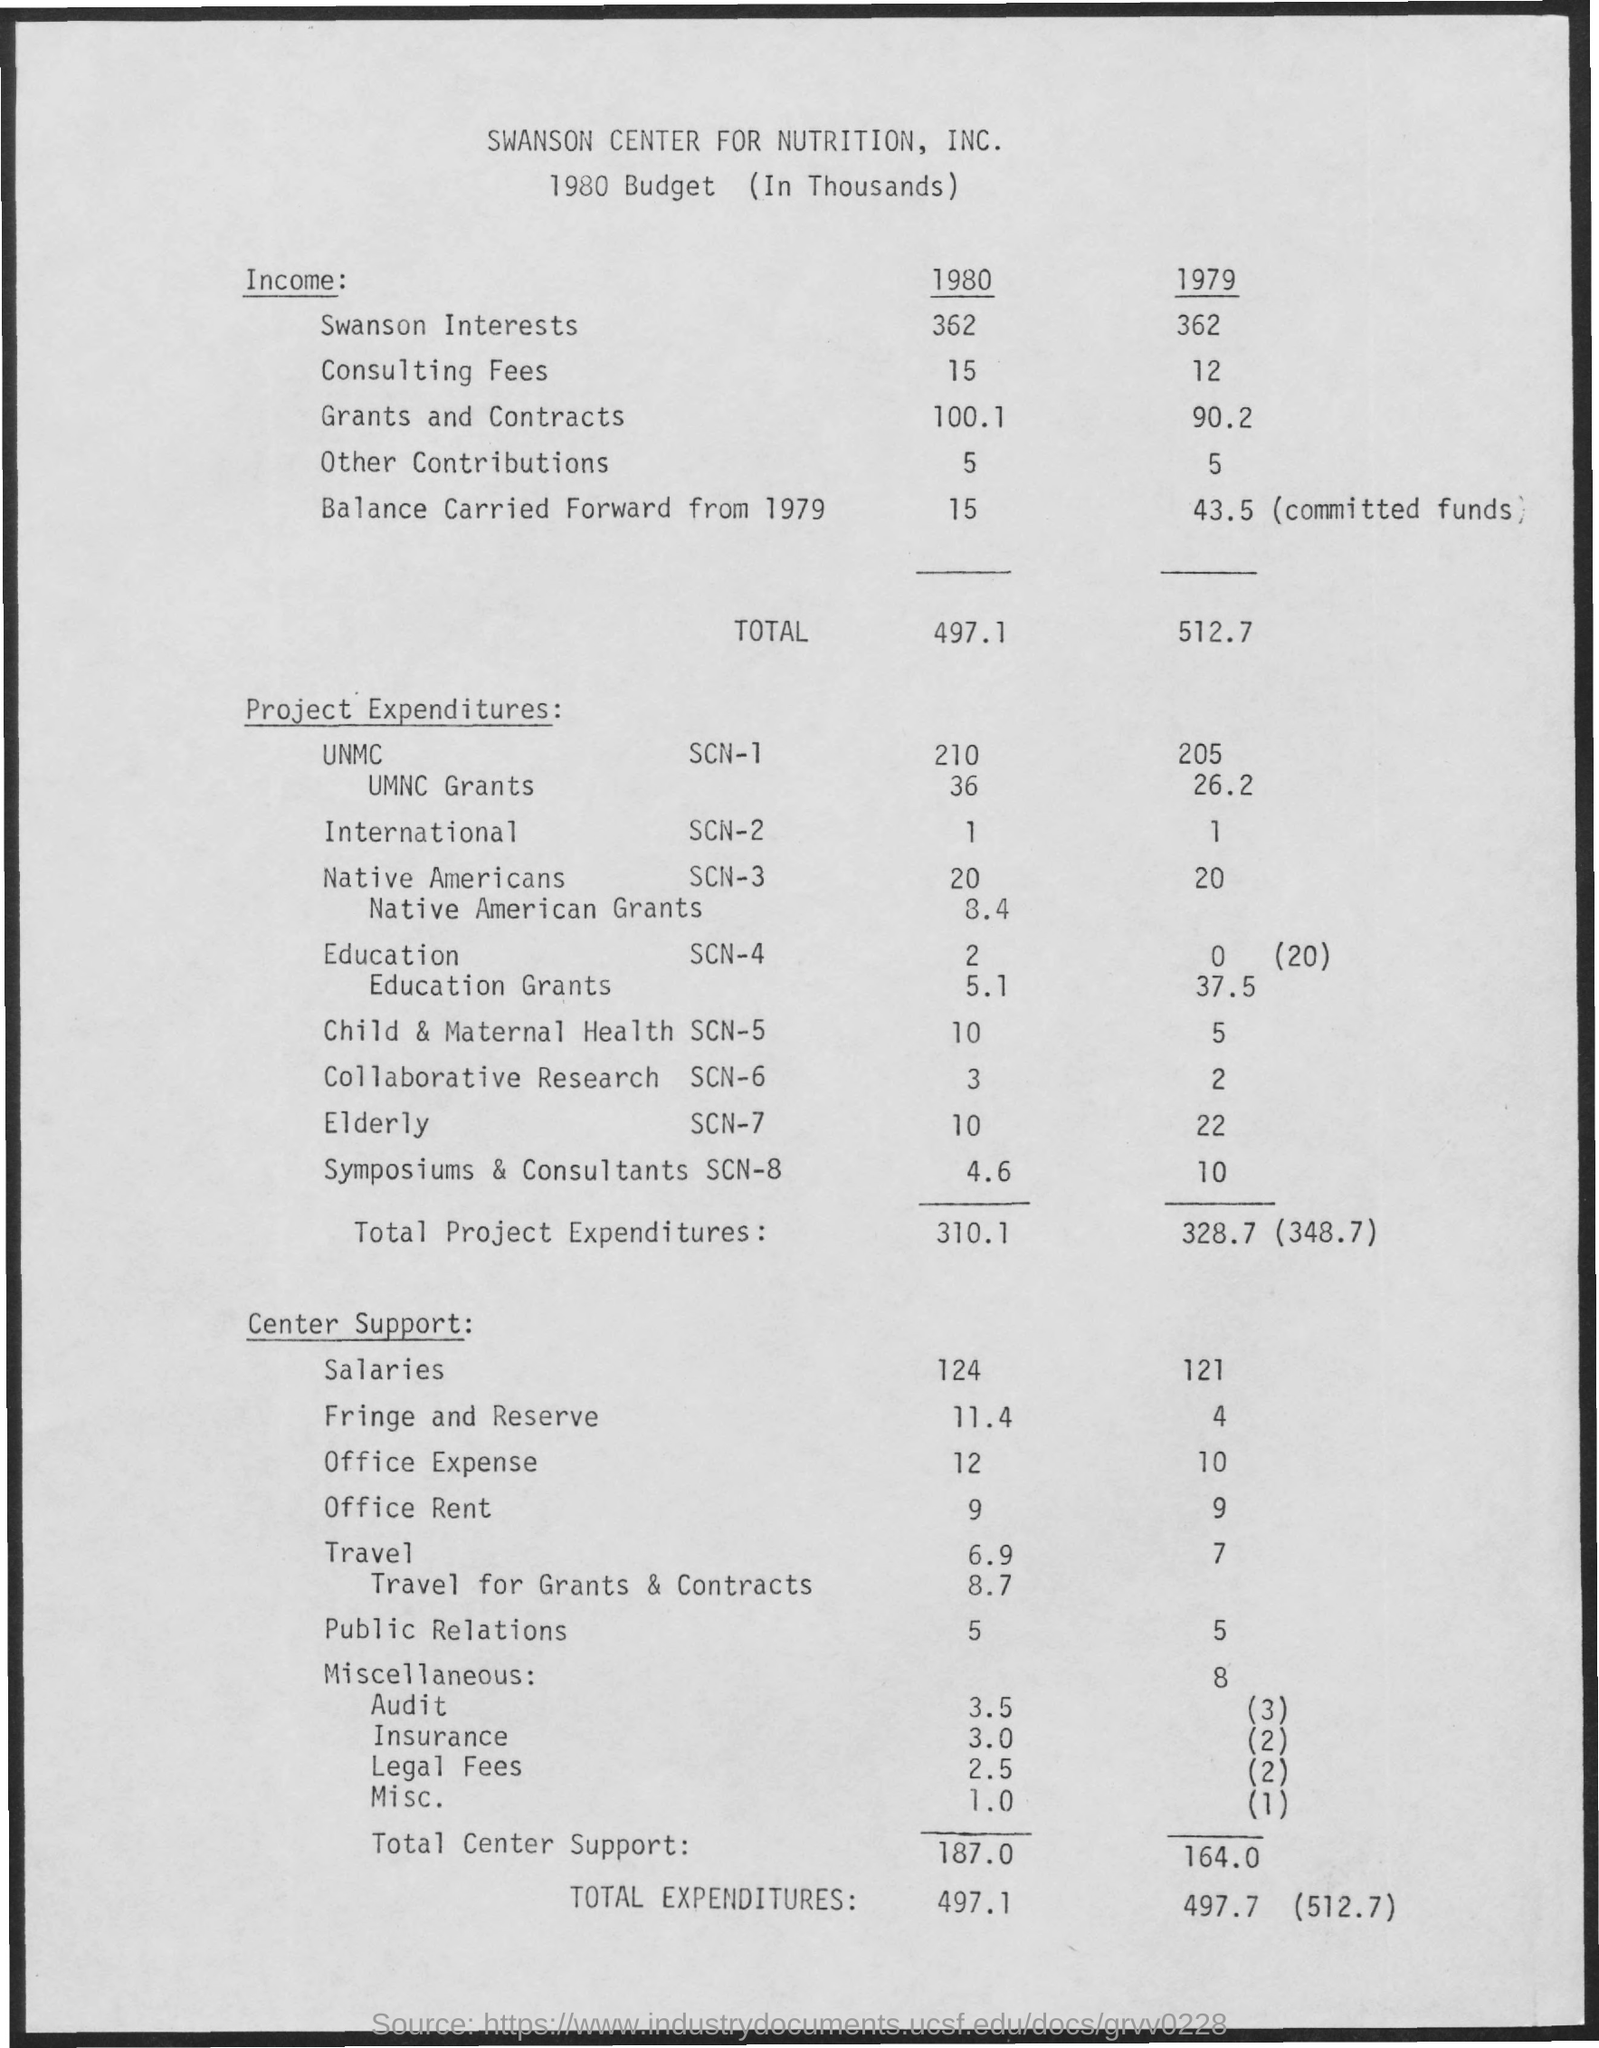What is the income value of swanson interests in 1980 ?
Give a very brief answer. 362. What is the income value of consulting fees in 1979?
Your response must be concise. 12. What is the income value of grants and contracts in the year 1980 ?
Provide a short and direct response. 100.1. What is the income value of other contributions in the year 1979 ?
Your answer should be very brief. 5. What is the total income value mentioned in the year 1980 ?
Your answer should be compact. 497.1. What is the total income value mentioned in the year 1979 ?
Offer a terse response. 512.7. What is the value of total project expenditures in the year 1979 ?
Provide a succinct answer. 328.7. What is the value of total project expenditures in the year 1980 ?
Your answer should be very brief. 310.1. What is the value of total center support for the year 1980 ?
Give a very brief answer. 187.0. What is the value of total center support for the year 1979 ?
Provide a succinct answer. 164.0. 